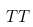<formula> <loc_0><loc_0><loc_500><loc_500>T \label t o { \rho } T</formula> 